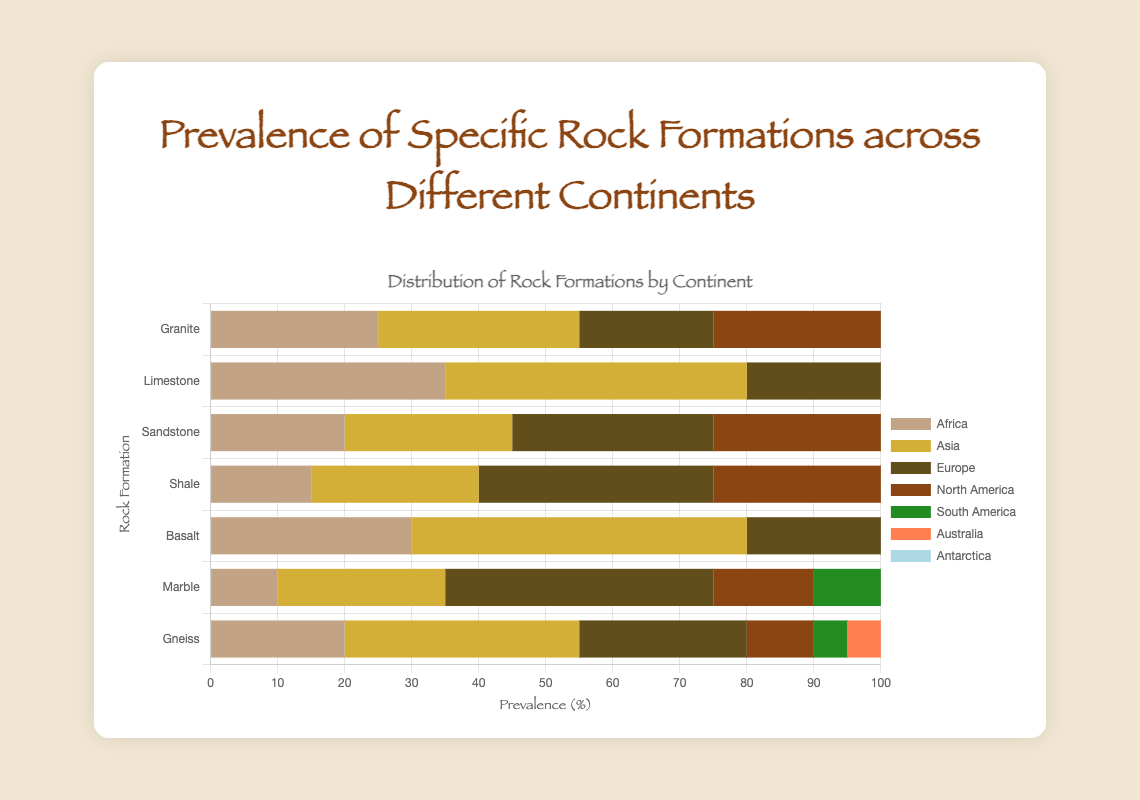Which continent has the highest prevalence of Granite? From the chart, North America has the highest bar for Granite.
Answer: North America Which rock formation is least prevalent in Antarctica? By observing the minimal bar lengths, Limestone and Marble both show no prevalence in Antarctica.
Answer: Limestone and Marble What is the difference in prevalence between Limestone and Sandstone in Asia? The prevalence of Limestone in Asia is 45, and Sandstone is 25. The difference is 45 - 25.
Answer: 20 Which continent shows the highest prevalence of Basalt? The tallest bar for Basalt is seen in Asia.
Answer: Asia What is the average prevalence of Marble across all continents? Sum the prevalence of Marble across all continents: 10 + 25 + 40 + 15 + 10 + 5 + 0 = 105. There are 7 continents, so divide by 7.
Answer: 15 Which rock formation has roughly the same prevalence in Europe and Africa? By comparing the bar heights, Basalt in Europe and Africa both have a prevalence close to 20.
Answer: Basalt Which two rock formations have the closest prevalence values in North America? Granite (40) and Sandstone (35) show the closest bars in length in North America.
Answer: Granite and Sandstone What is the total prevalence of Gneiss across Europe, Asia, and Africa? Sum the prevalence of Gneiss in Europe (25), Asia (35), and Africa (20). The total is 25 + 35 + 20.
Answer: 80 Compare the prevalence of Shale in South America and Antarctica. Which is higher? Shale in South America has a value of 10, whereas in Antarctica it is 3. Hence, South America is higher.
Answer: South America In which continent is the prevalence of Marble exactly double that of Australia? Marble in Australia is 5. The continent with Marble prevalence of 10, which is double of 5, is Africa.
Answer: Africa 